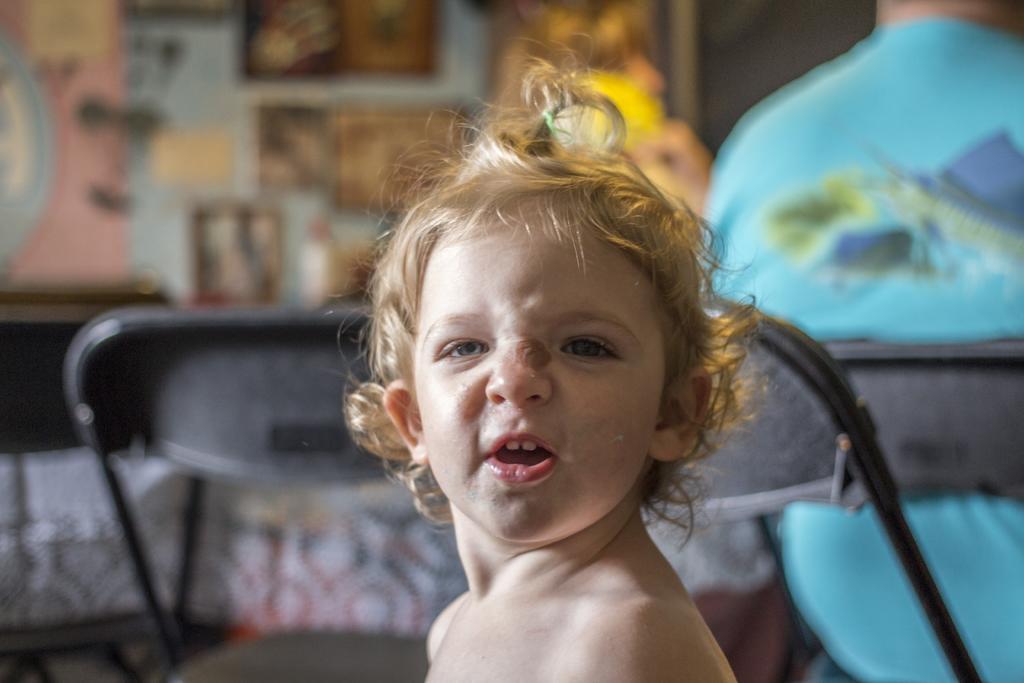Could you give a brief overview of what you see in this image? This image consists of a kid. On the right, we can see a person wearing a blue t-shirt is sitting in a chair. Behind the kid, there is another chair. In the background, there is wall on which there are many frames,. And the background is blurred. 